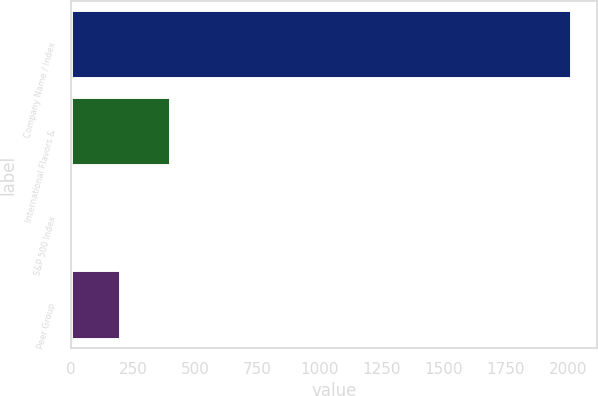Convert chart to OTSL. <chart><loc_0><loc_0><loc_500><loc_500><bar_chart><fcel>Company Name / Index<fcel>International Flavors &<fcel>S&P 500 Index<fcel>Peer Group<nl><fcel>2015<fcel>404.1<fcel>1.38<fcel>202.74<nl></chart> 